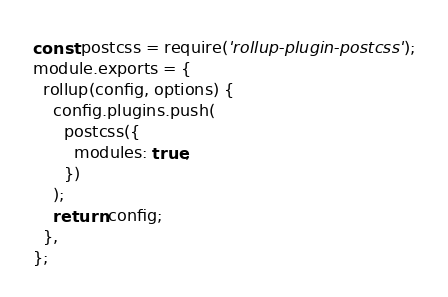Convert code to text. <code><loc_0><loc_0><loc_500><loc_500><_JavaScript_>const postcss = require('rollup-plugin-postcss');
module.exports = {
  rollup(config, options) {
    config.plugins.push(
      postcss({
        modules: true,
      })
    );
    return config;
  },
};</code> 